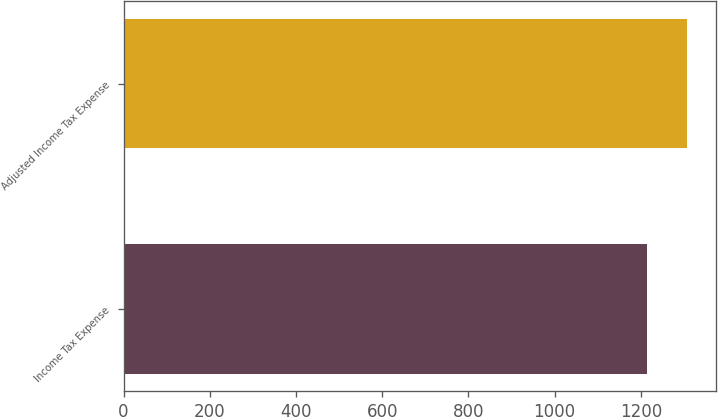<chart> <loc_0><loc_0><loc_500><loc_500><bar_chart><fcel>Income Tax Expense<fcel>Adjusted Income Tax Expense<nl><fcel>1214<fcel>1308<nl></chart> 